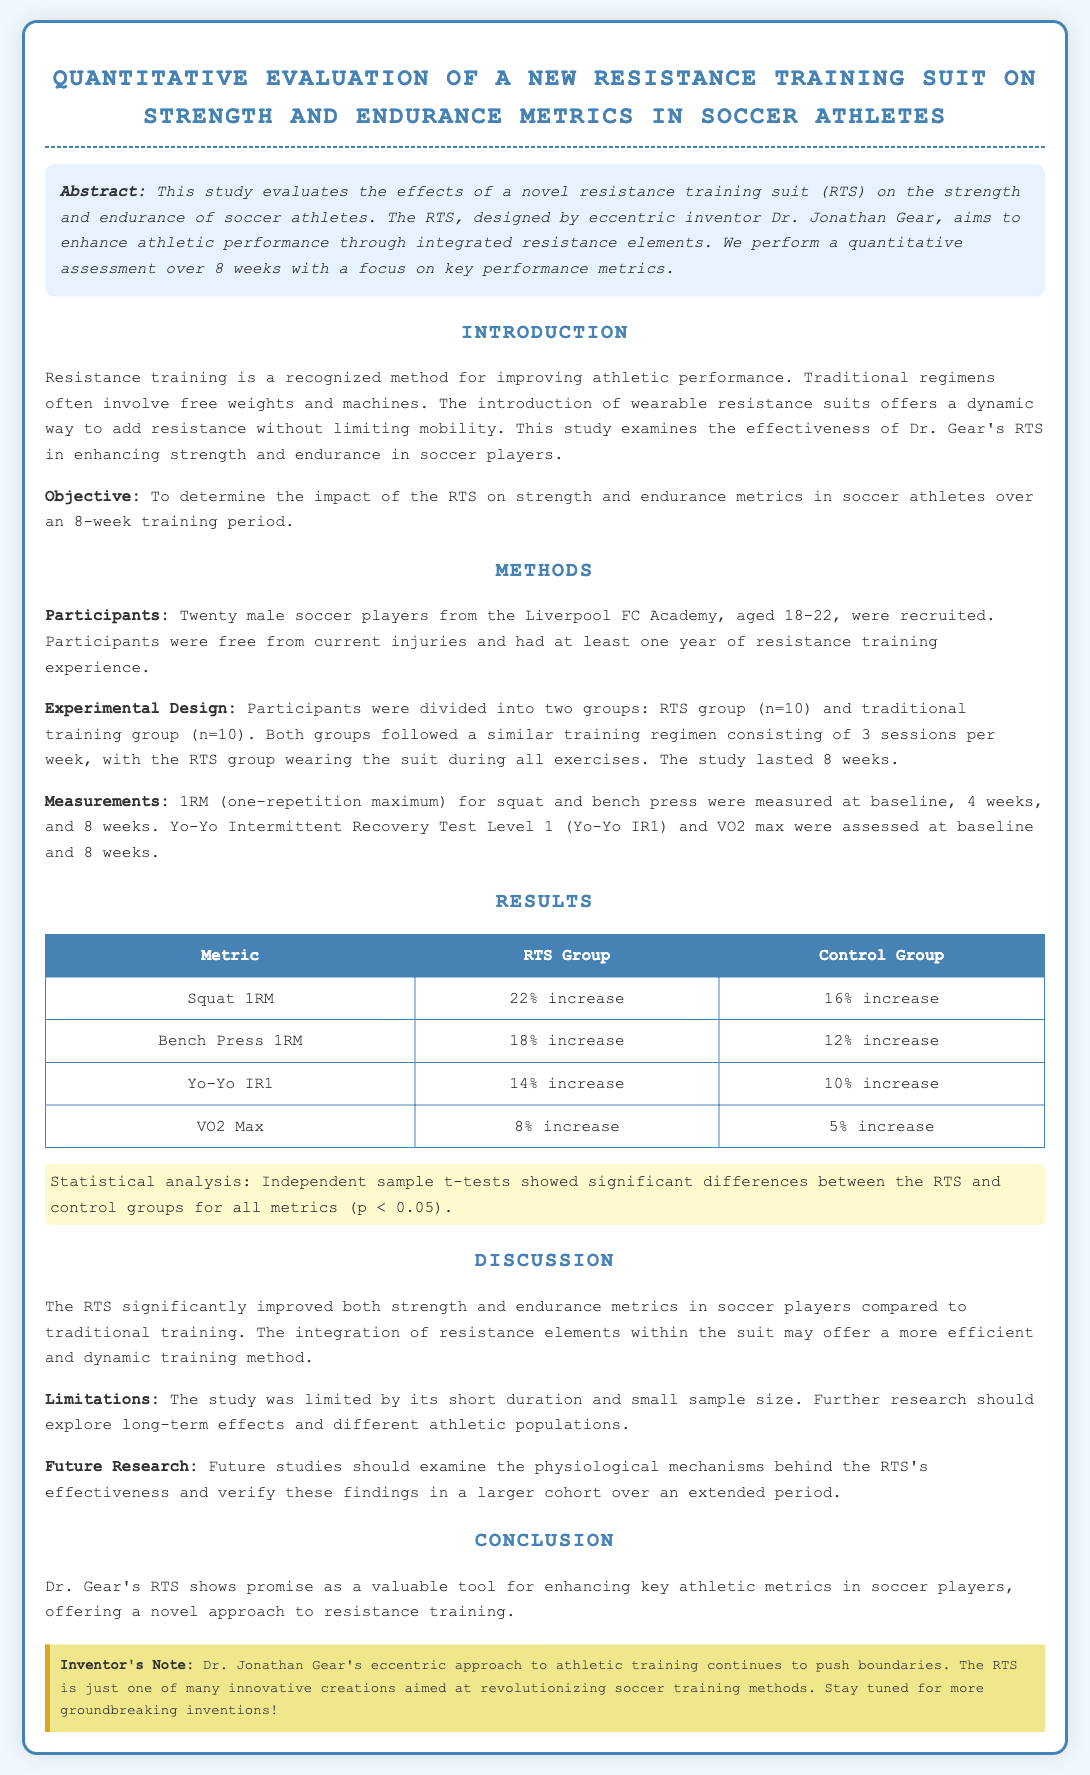What is the title of the study? The title of the study is stated clearly at the beginning of the document.
Answer: Quantitative Evaluation of a New Resistance Training Suit on Strength and Endurance Metrics in Soccer Athletes Who designed the resistance training suit? The inventor's name is mentioned in the abstract and introduction sections of the document.
Answer: Dr. Jonathan Gear How many participants were in the RTS group? The document specifies the number of participants in the RTS group during the methods section.
Answer: 10 What was the percentage increase in squat 1RM for the RTS group? The results table provides the exact percentage increase for squat 1RM for the RTS group.
Answer: 22% increase What statistical test was used in the study? The methodology specifies the type of statistical analysis performed to evaluate the results.
Answer: Independent sample t-tests What limitation is mentioned in the discussion? The limitations of the study are clearly stated in the discussion section.
Answer: Short duration and small sample size What is the major conclusion of the study? The conclusion summarizes the primary finding of the study regarding the RTS's effectiveness.
Answer: Enhanced key athletic metrics in soccer players What should future research examine according to the report? The document outlines suggestions for future research in the discussion section.
Answer: Physiological mechanisms behind the RTS's effectiveness 